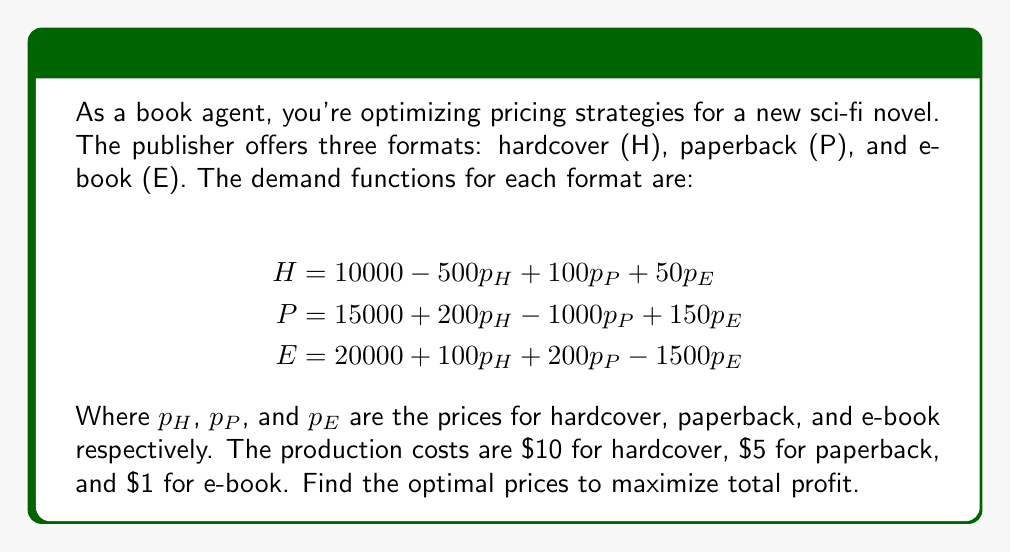Solve this math problem. To solve this problem, we'll follow these steps:

1) First, let's write the profit function. Profit = Revenue - Cost
   $$\pi = p_H H + p_P P + p_E E - 10H - 5P - E$$

2) Substitute the demand functions:
   $$\pi = p_H(10000 - 500p_H + 100p_P + 50p_E) + p_P(15000 + 200p_H - 1000p_P + 150p_E) + p_E(20000 + 100p_H + 200p_P - 1500p_E) - 10(10000 - 500p_H + 100p_P + 50p_E) - 5(15000 + 200p_H - 1000p_P + 150p_E) - (20000 + 100p_H + 200p_P - 1500p_E)$$

3) To maximize profit, we need to find where the partial derivatives with respect to each price equal zero:

   $$\frac{\partial \pi}{\partial p_H} = 10000 - 1000p_H + 100p_P + 50p_E + 200p_P + 100p_E + 5000 - 1000 - 500 = 0$$
   $$\frac{\partial \pi}{\partial p_P} = 100p_H + 15000 - 2000p_P + 150p_E + 200p_E - 500 + 5000 - 1000 = 0$$
   $$\frac{\partial \pi}{\partial p_E} = 50p_H + 150p_P + 20000 - 3000p_E + 100p_H + 200p_P - 250 - 750 + 1500 = 0$$

4) Simplify:
   $$-1000p_H + 300p_P + 150p_E = -13500$$
   $$100p_H - 2000p_P + 350p_E = -18500$$
   $$150p_H + 350p_P - 3000p_E = -20500$$

5) Solve this system of equations. Using matrix methods or substitution:
   $$p_H = 30$$
   $$p_P = 20$$
   $$p_E = 10$$

6) Verify that this is indeed a maximum by checking the second derivatives (omitted for brevity).
Answer: Optimal prices: Hardcover $\$30$, Paperback $\$20$, E-book $\$10$ 